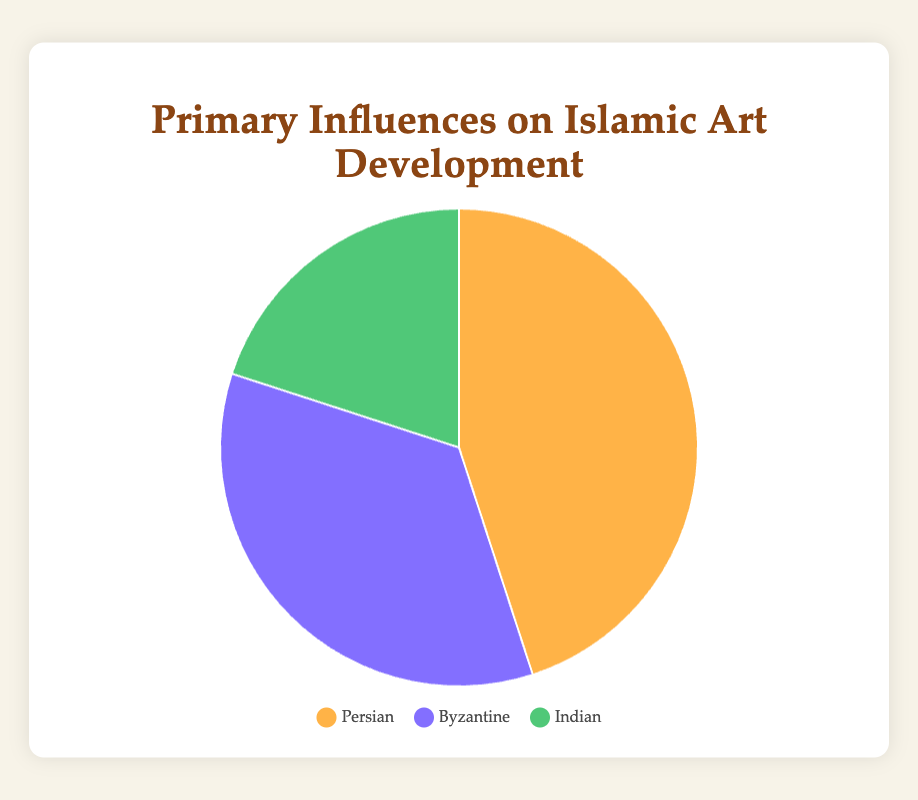What percentage of Islamic art influences are derived from Persian culture? The pie chart shows that the Persian influence contributes 45% to Islamic art development. This information is directly visible.
Answer: 45% How much more does Persian influence contribute compared to Indian influence? To find this, subtract the contribution percentage of Indian (20%) from that of Persian (45%): 45% - 20% = 25%.
Answer: 25% What is the combined contribution percentage of Byzantine and Indian influences? Add the contribution percentages of Byzantine (35%) and Indian (20%): 35% + 20% = 55%.
Answer: 55% Which influence has the smallest contribution to the development of Islamic art? By comparing the percentages, Indian influence has the smallest contribution at 20%.
Answer: Indian Are the contributions from Persian and Byzantine influences greater or less than 75% when combined? Add the contribution percentages of Persian (45%) and Byzantine (35%): 45% + 35% = 80%. Since 80% is greater than 75%, the answer is greater.
Answer: Greater Which influence can be associated with mosaics and domes? The pie chart indicates that Byzantine influence includes major elements like mosaics and domes.
Answer: Byzantine What is the difference in percentage points between the influence with the highest and the lowest contribution? Subtract the smallest contribution percentage (Indian, 20%) from the highest (Persian, 45%): 45% - 20% = 25%.
Answer: 25% What are the visual colors representing Persian and Byzantine influences respectively? The legend indicates that Persian is represented by an orangeish color and Byzantine by a purplish color.
Answer: Orangeish, Purplish What visual clues help you identify Indian influence in the pie chart? The legend shows that Indian influence is represented by a greenish color on the pie chart.
Answer: Greenish What is the average percentage contribution of all three influences? Add the contributions (45% Persian, 35% Byzantine, 20% Indian) and divide by the number of influences: (45% + 35% + 20%) / 3 = 33.33%.
Answer: 33.33% 